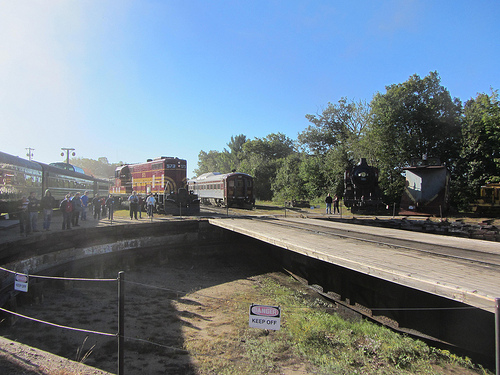Describe the overall mood of the image and what kind of story it might be telling. The overall mood of the image seems to be calm and nostalgic, reminiscent of a peaceful day at a rural train station. It might be telling the story of travelers starting a journey, people visiting a historical train site, or a leisurely day watching trains pass by. Can you imagine what sounds might be heard in this image? In this image, you might hear the distant rumble of train engines, the chugging sound of a steam locomotive, the murmur of people chatting on the platform, and perhaps the rustling of leaves in the gentle breeze. The occasional horn of a train might punctuate the ambiance, adding a lively element to the serene setting. Envision a night-time version of this scene. How would it look and what differences might there be? At night, this scene would transform dramatically. The sky would be adorned with stars, creating a sparkling canopy above the station. The platform and trains would be illuminated by soft, warm lights, casting long shadows that dance with the movement of people. The red train would gleam under the station lights, its colors slightly muted by the darkness. Sounds would be quieter, with the occasional murmur of conversation and the distant whistle of a train echoing in the stillness. The mood would shift to a more mysterious and contemplative atmosphere, inviting stories of late-night journeys and whispered conversations. 